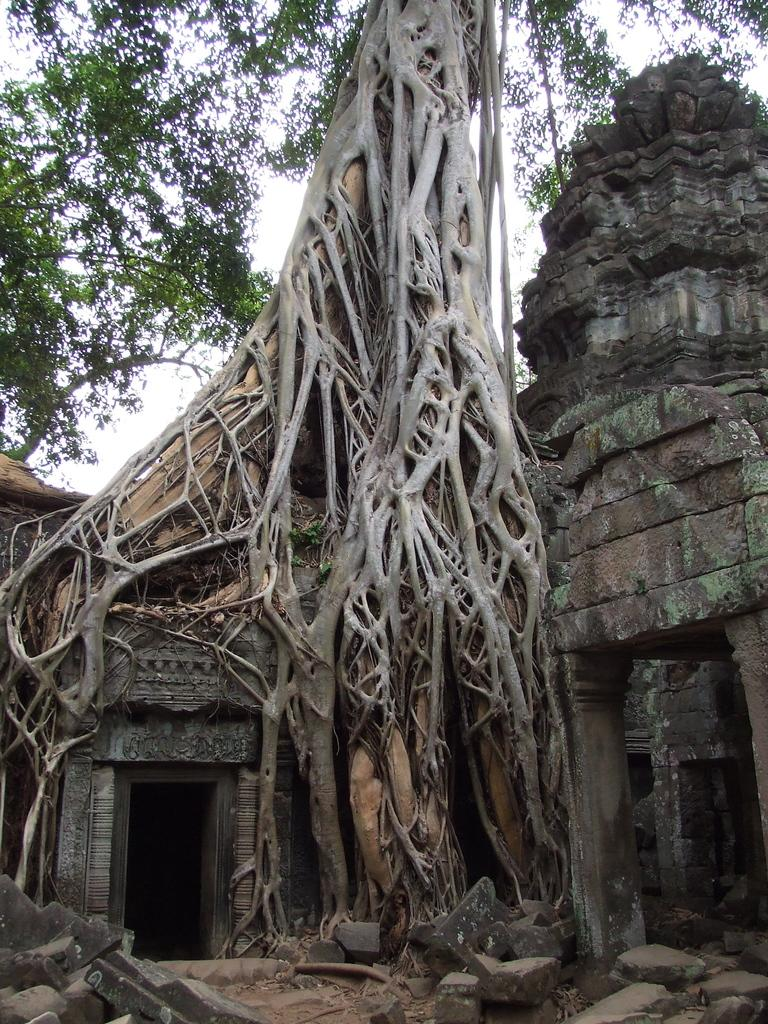What type of structure is visible in the image? There is a temple made of stones in the image. What natural elements can be seen in the image? There are trees visible in the image. What material is used to construct the temple? The temple is made of stones. Can you describe the base of the image? Stones are present at the bottom of the image. What part of a tree can be seen at the bottom of the image? The stem of a tree is visible at the bottom of the image. What type of frame surrounds the temple in the image? There is no frame surrounding the temple in the image; it is a standalone structure. How does the baby contribute to the construction of the temple in the image? There is no baby present in the image, so it cannot contribute to the construction of the temple. 